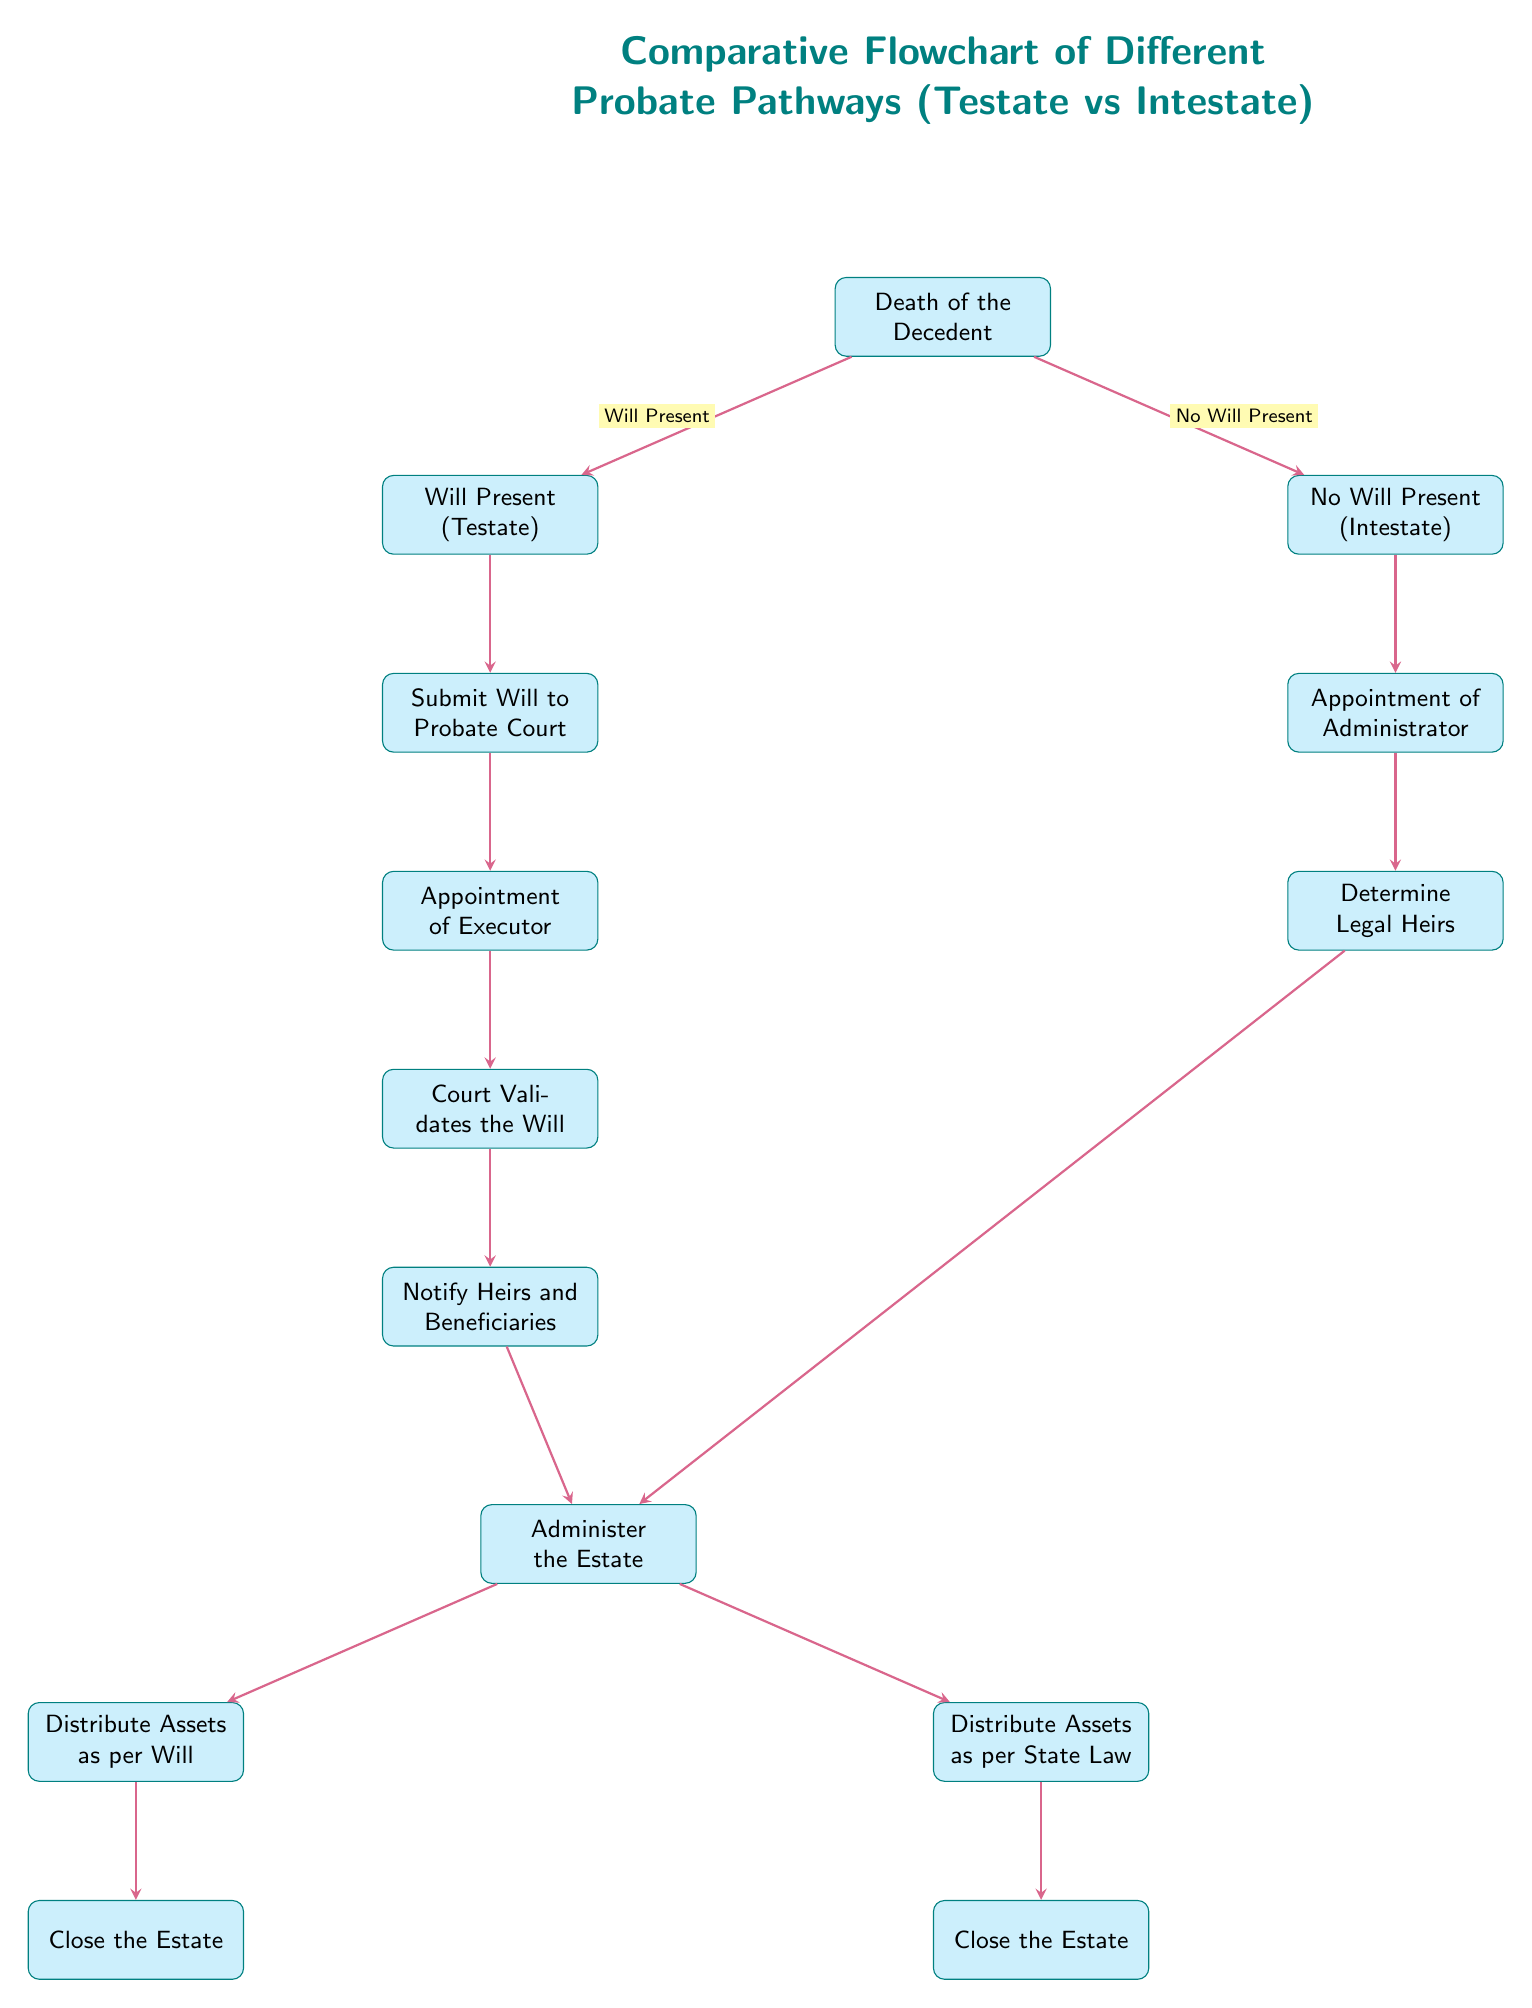What are the two main pathways depicted in the diagram? The diagram distinguishes between two main pathways: Testate (with a will) and Intestate (without a will). This is directly illustrated at the first split after the "Death of the Decedent" node.
Answer: Testate, Intestate What action is taken first in the Testate pathway? The first action in the Testate pathway, as shown in the diagram, is the submission of the will to the probate court, following the node directly below Testate.
Answer: Submit Will to Probate Court How many steps are there in the Testate pathway? The Testate pathway consists of five distinct steps: "Submit Will to Probate Court," "Appointment of Executor," "Court Validates the Will," "Notify Heirs and Beneficiaries," and "Administer the Estate," making a total of five steps.
Answer: Five What role is appointed in the Intestate pathway? In the Intestate pathway, the first role appointed is the Administrator, as indicated in the node directly below Intestate.
Answer: Administrator What happens after administering the estate in both pathways? After administering the estate, both pathways lead to different nodes: Testate leads to "Distribute Assets as per Will," while Intestate leads to "Distribute Assets as per State Law." This is evident from the flow that branches off from the "Administer the Estate" node.
Answer: Distribute Assets Which pathway requires validating a will? The Testate pathway requires the validation of a will as part of its process steps. This step is explicitly shown in the diagram under the sequence for Testate.
Answer: Testate How many nodes correspond to the closure of the estate? There are two nodes corresponding to the closure of the estate: "Close the Estate" for Testate and "Close the Estate" for Intestate, indicating there is one closure step per pathway.
Answer: Two What is the last action taken in both pathways? The last action in both pathways, regardless of the different preceding steps, is to close the estate, depicted as two separate nodes for Testate and Intestate preceding the closure action.
Answer: Close the Estate 